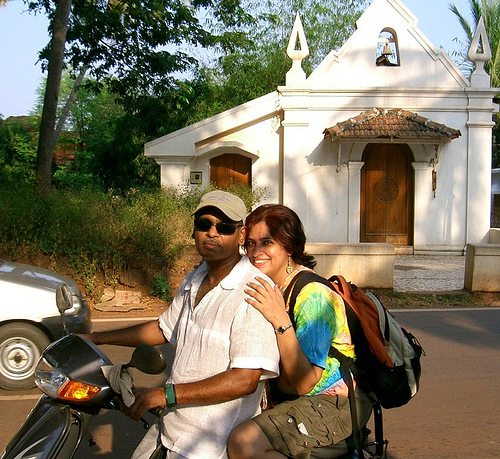What's happening in the scene? In the image, there is a man and a woman riding a scooter on a sunny day. They appear to be traveling, as suggested by the backpack carried by the woman. Their casual attire and sunglasses indicate leisure or tourist activity, possibly exploring the area near a traditional-looking building in the background. Both individuals seem relaxed, and the woman is smiling, which could suggest they are enjoying their ride. 